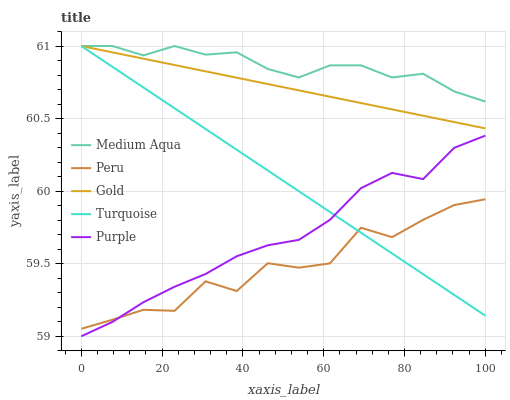Does Peru have the minimum area under the curve?
Answer yes or no. Yes. Does Medium Aqua have the maximum area under the curve?
Answer yes or no. Yes. Does Turquoise have the minimum area under the curve?
Answer yes or no. No. Does Turquoise have the maximum area under the curve?
Answer yes or no. No. Is Gold the smoothest?
Answer yes or no. Yes. Is Peru the roughest?
Answer yes or no. Yes. Is Turquoise the smoothest?
Answer yes or no. No. Is Turquoise the roughest?
Answer yes or no. No. Does Purple have the lowest value?
Answer yes or no. Yes. Does Turquoise have the lowest value?
Answer yes or no. No. Does Gold have the highest value?
Answer yes or no. Yes. Does Peru have the highest value?
Answer yes or no. No. Is Purple less than Medium Aqua?
Answer yes or no. Yes. Is Medium Aqua greater than Peru?
Answer yes or no. Yes. Does Gold intersect Medium Aqua?
Answer yes or no. Yes. Is Gold less than Medium Aqua?
Answer yes or no. No. Is Gold greater than Medium Aqua?
Answer yes or no. No. Does Purple intersect Medium Aqua?
Answer yes or no. No. 